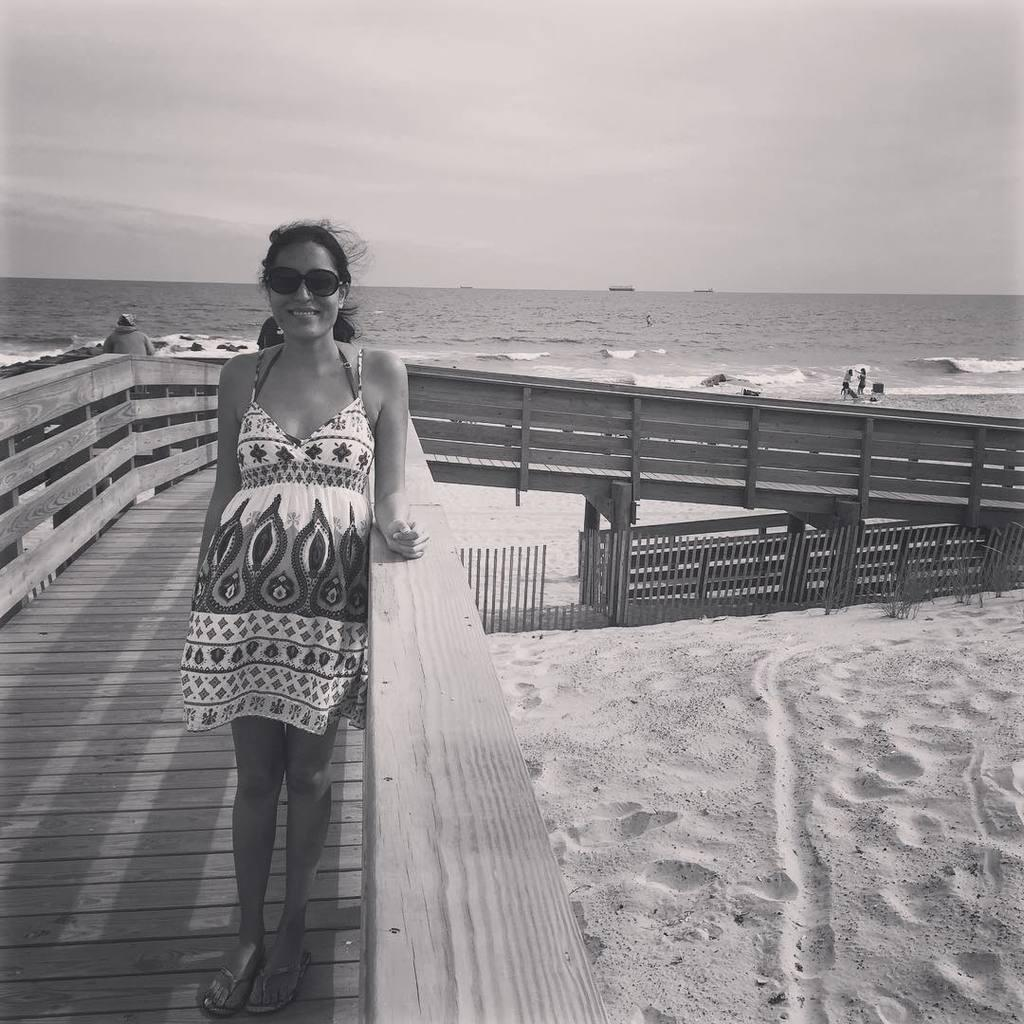Who or what can be seen in the image? There are people in the image. Can you describe the lady's position in the image? A lady is standing on a wooden path. What can be seen in the background of the image? The sky is visible in the image. What natural feature is present in the image? The ocean is present in the image. What type of authority does the lady have over the ocean in the image? There is no indication of the lady having any authority over the ocean in the image. Can you describe the lady's head in the image? The lady's head is not visible in the image, as she is facing away from the camera. 